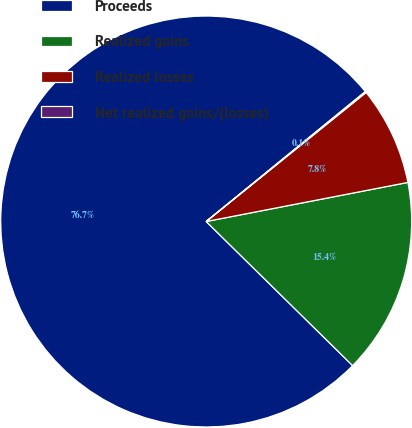Convert chart to OTSL. <chart><loc_0><loc_0><loc_500><loc_500><pie_chart><fcel>Proceeds<fcel>Realized gains<fcel>Realized losses<fcel>Net realized gains/(losses)<nl><fcel>76.73%<fcel>15.42%<fcel>7.76%<fcel>0.09%<nl></chart> 